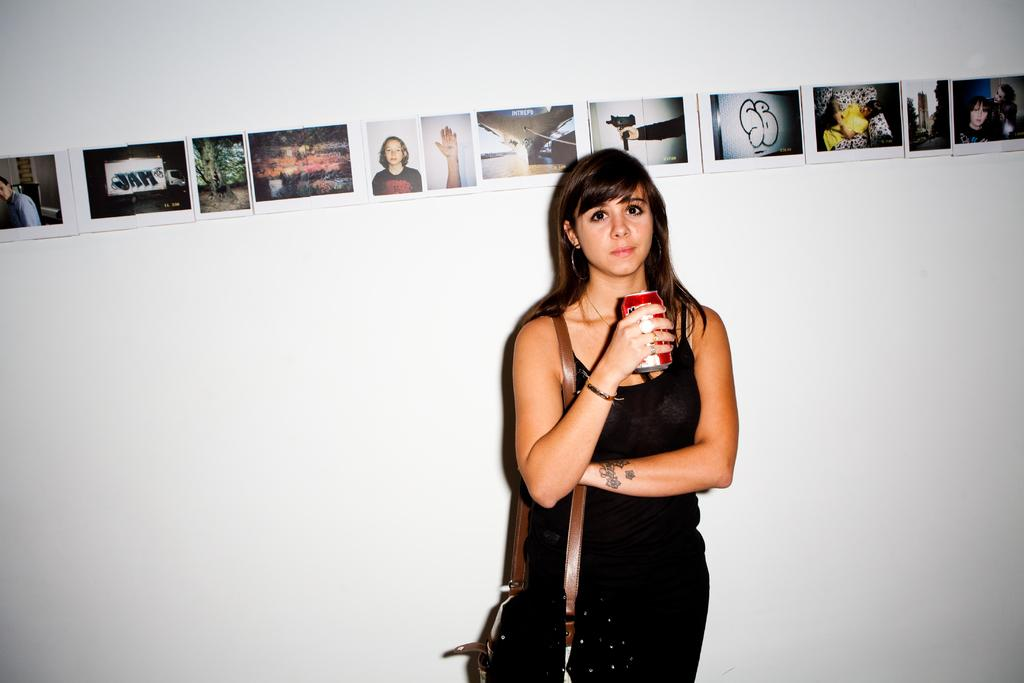Who is the main subject in the image? There is a girl in the image. What is the girl doing in the image? The girl is standing. What is the girl holding in the image? The girl is holding a coke can. What can be seen on the wall in the image? There is a white color wall in the image, and there are pictures pasted on the wall. What type of volleyball is the girl playing in the image? There is no volleyball present in the image; the girl is holding a coke can. What ingredients are used to make the stew in the image? There is no stew present in the image; the girl is holding a coke can. 